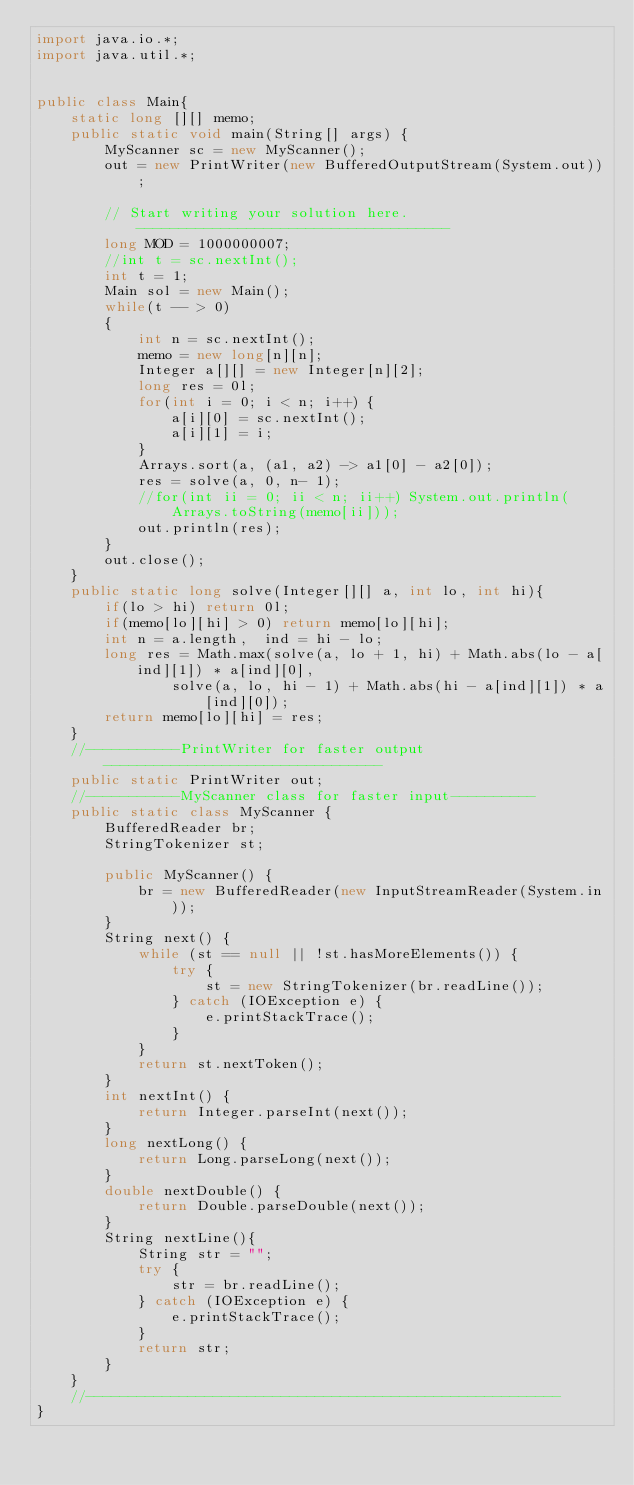<code> <loc_0><loc_0><loc_500><loc_500><_Java_>import java.io.*;
import java.util.*;


public class Main{
    static long [][] memo;
    public static void main(String[] args) {
        MyScanner sc = new MyScanner();
        out = new PrintWriter(new BufferedOutputStream(System.out));

        // Start writing your solution here. -------------------------------------
        long MOD = 1000000007;
        //int t = sc.nextInt();
        int t = 1;
        Main sol = new Main();
        while(t -- > 0)
        {
            int n = sc.nextInt();
            memo = new long[n][n];
            Integer a[][] = new Integer[n][2];
            long res = 0l;
            for(int i = 0; i < n; i++) {
                a[i][0] = sc.nextInt();
                a[i][1] = i;
            }
            Arrays.sort(a, (a1, a2) -> a1[0] - a2[0]);
            res = solve(a, 0, n- 1);
            //for(int ii = 0; ii < n; ii++) System.out.println(Arrays.toString(memo[ii]));
            out.println(res);
        }
        out.close();
    }
    public static long solve(Integer[][] a, int lo, int hi){
        if(lo > hi) return 0l;
        if(memo[lo][hi] > 0) return memo[lo][hi];
        int n = a.length,  ind = hi - lo;
        long res = Math.max(solve(a, lo + 1, hi) + Math.abs(lo - a[ind][1]) * a[ind][0],
                solve(a, lo, hi - 1) + Math.abs(hi - a[ind][1]) * a[ind][0]);
        return memo[lo][hi] = res;
    }
    //-----------PrintWriter for faster output---------------------------------
    public static PrintWriter out;
    //-----------MyScanner class for faster input----------
    public static class MyScanner {
        BufferedReader br;
        StringTokenizer st;

        public MyScanner() {
            br = new BufferedReader(new InputStreamReader(System.in));
        }
        String next() {
            while (st == null || !st.hasMoreElements()) {
                try {
                    st = new StringTokenizer(br.readLine());
                } catch (IOException e) {
                    e.printStackTrace();
                }
            }
            return st.nextToken();
        }
        int nextInt() {
            return Integer.parseInt(next());
        }
        long nextLong() {
            return Long.parseLong(next());
        }
        double nextDouble() {
            return Double.parseDouble(next());
        }
        String nextLine(){
            String str = "";
            try {
                str = br.readLine();
            } catch (IOException e) {
                e.printStackTrace();
            }
            return str;
        }
    }
    //--------------------------------------------------------
}
</code> 